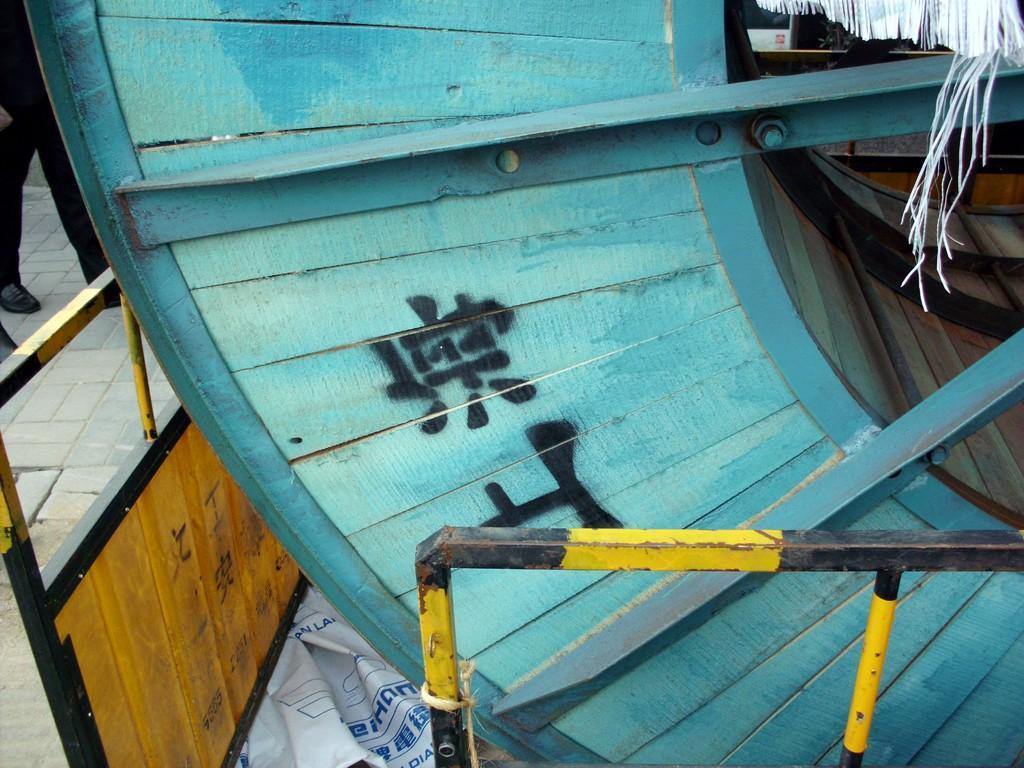Describe this image in one or two sentences. In a given image i can see a wooden object,railing and people. 